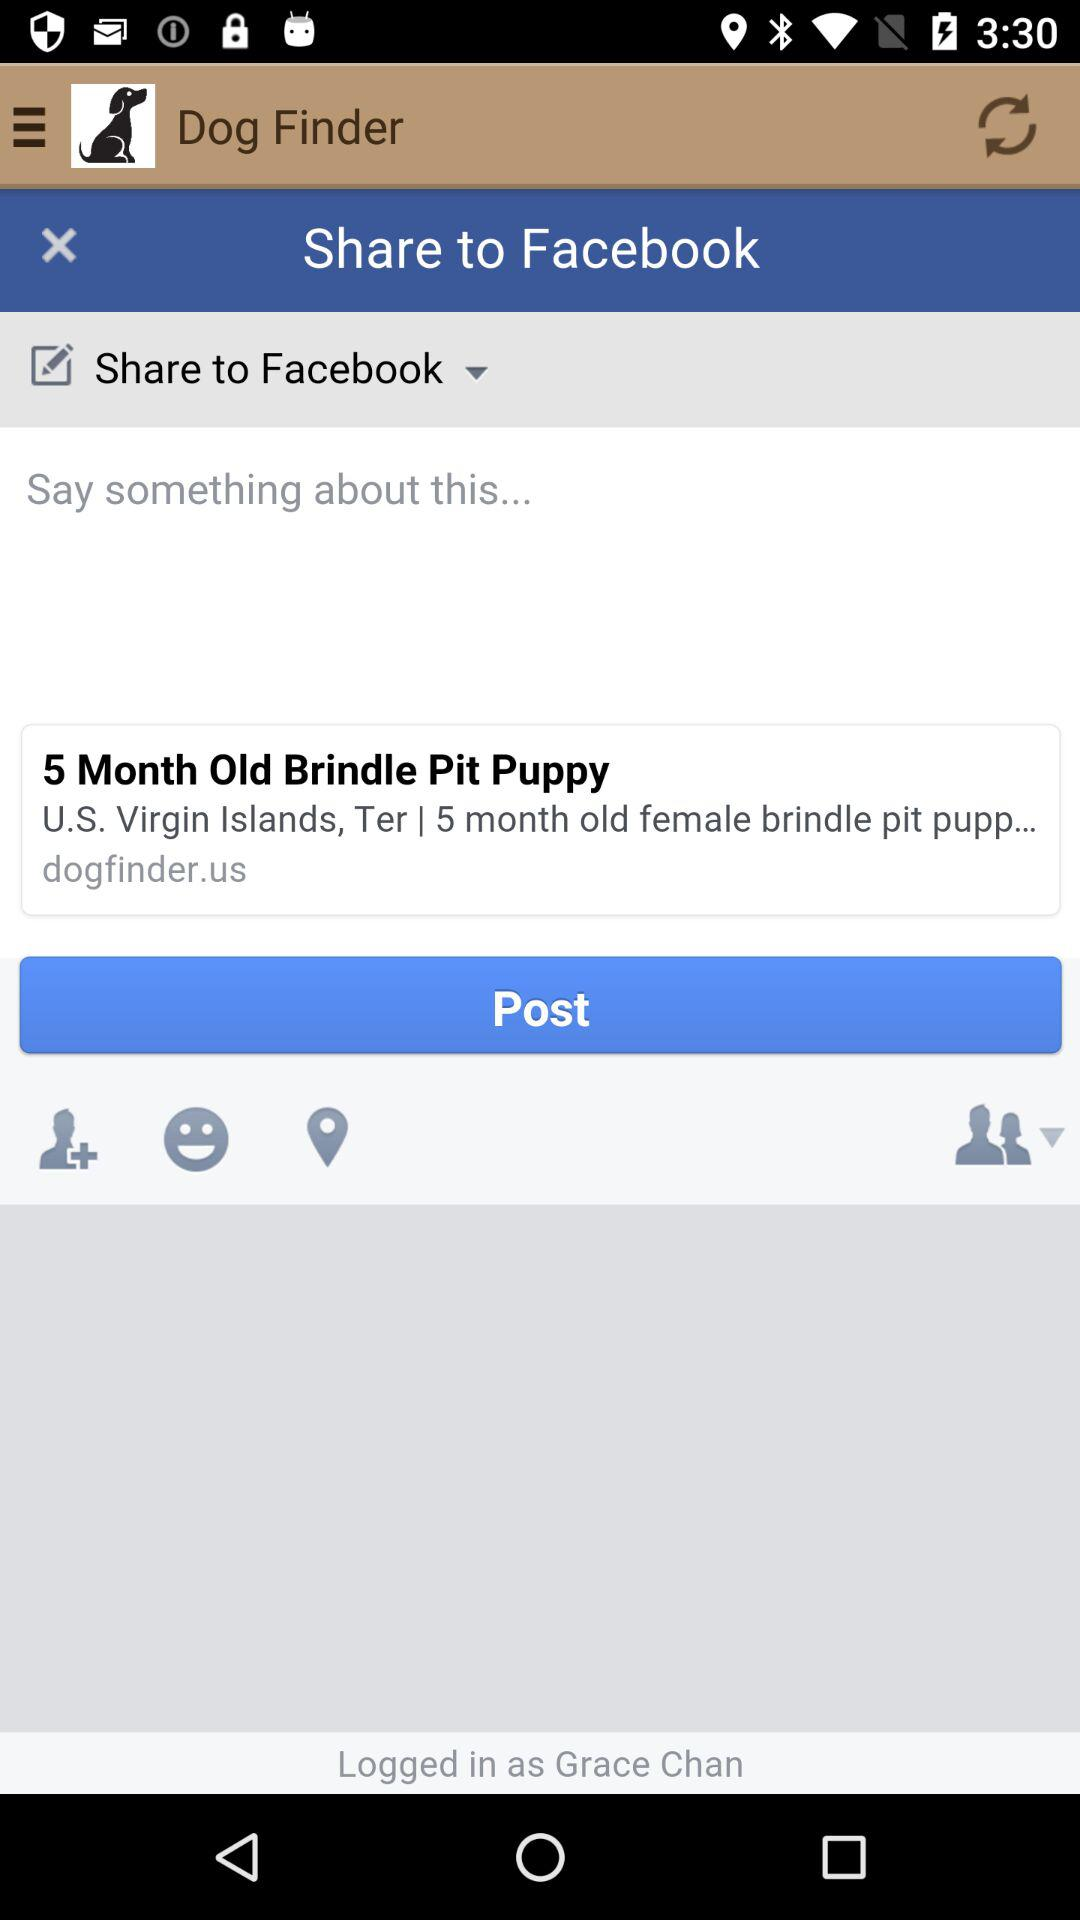Where can we share the post? You can share the post on "Facebook". 